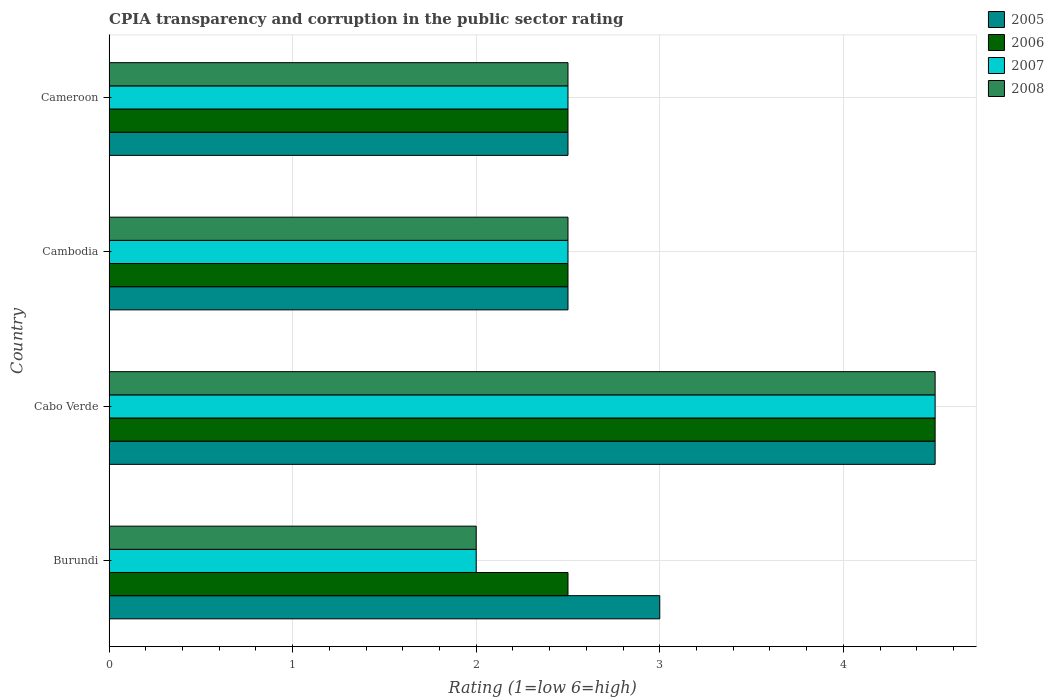How many groups of bars are there?
Make the answer very short. 4. Are the number of bars on each tick of the Y-axis equal?
Provide a short and direct response. Yes. How many bars are there on the 1st tick from the bottom?
Offer a very short reply. 4. What is the label of the 2nd group of bars from the top?
Your response must be concise. Cambodia. Across all countries, what is the maximum CPIA rating in 2006?
Provide a succinct answer. 4.5. Across all countries, what is the minimum CPIA rating in 2007?
Offer a very short reply. 2. In which country was the CPIA rating in 2008 maximum?
Your answer should be very brief. Cabo Verde. In which country was the CPIA rating in 2007 minimum?
Offer a terse response. Burundi. What is the difference between the CPIA rating in 2007 in Burundi and that in Cameroon?
Make the answer very short. -0.5. What is the average CPIA rating in 2007 per country?
Ensure brevity in your answer.  2.88. What is the difference between the highest and the lowest CPIA rating in 2008?
Offer a terse response. 2.5. In how many countries, is the CPIA rating in 2005 greater than the average CPIA rating in 2005 taken over all countries?
Your answer should be very brief. 1. What does the 3rd bar from the top in Burundi represents?
Offer a very short reply. 2006. Are all the bars in the graph horizontal?
Give a very brief answer. Yes. How many countries are there in the graph?
Provide a short and direct response. 4. What is the difference between two consecutive major ticks on the X-axis?
Ensure brevity in your answer.  1. Where does the legend appear in the graph?
Offer a terse response. Top right. How many legend labels are there?
Your response must be concise. 4. How are the legend labels stacked?
Offer a very short reply. Vertical. What is the title of the graph?
Provide a succinct answer. CPIA transparency and corruption in the public sector rating. What is the label or title of the Y-axis?
Offer a terse response. Country. What is the Rating (1=low 6=high) in 2005 in Burundi?
Provide a short and direct response. 3. What is the Rating (1=low 6=high) in 2006 in Burundi?
Make the answer very short. 2.5. What is the Rating (1=low 6=high) in 2007 in Burundi?
Your answer should be very brief. 2. What is the Rating (1=low 6=high) in 2008 in Burundi?
Provide a short and direct response. 2. What is the Rating (1=low 6=high) of 2005 in Cabo Verde?
Your answer should be compact. 4.5. What is the Rating (1=low 6=high) in 2008 in Cabo Verde?
Give a very brief answer. 4.5. What is the Rating (1=low 6=high) of 2006 in Cambodia?
Offer a very short reply. 2.5. What is the Rating (1=low 6=high) in 2007 in Cambodia?
Your answer should be very brief. 2.5. What is the Rating (1=low 6=high) of 2006 in Cameroon?
Keep it short and to the point. 2.5. What is the Rating (1=low 6=high) of 2007 in Cameroon?
Offer a terse response. 2.5. Across all countries, what is the maximum Rating (1=low 6=high) of 2005?
Give a very brief answer. 4.5. Across all countries, what is the maximum Rating (1=low 6=high) in 2006?
Offer a very short reply. 4.5. Across all countries, what is the maximum Rating (1=low 6=high) in 2007?
Make the answer very short. 4.5. Across all countries, what is the maximum Rating (1=low 6=high) in 2008?
Your answer should be compact. 4.5. Across all countries, what is the minimum Rating (1=low 6=high) in 2006?
Ensure brevity in your answer.  2.5. Across all countries, what is the minimum Rating (1=low 6=high) in 2008?
Keep it short and to the point. 2. What is the total Rating (1=low 6=high) in 2006 in the graph?
Your answer should be very brief. 12. What is the total Rating (1=low 6=high) of 2007 in the graph?
Offer a terse response. 11.5. What is the difference between the Rating (1=low 6=high) of 2005 in Burundi and that in Cabo Verde?
Keep it short and to the point. -1.5. What is the difference between the Rating (1=low 6=high) in 2007 in Burundi and that in Cambodia?
Your answer should be very brief. -0.5. What is the difference between the Rating (1=low 6=high) in 2006 in Cabo Verde and that in Cambodia?
Your answer should be compact. 2. What is the difference between the Rating (1=low 6=high) of 2007 in Cabo Verde and that in Cambodia?
Your answer should be compact. 2. What is the difference between the Rating (1=low 6=high) of 2008 in Cabo Verde and that in Cambodia?
Provide a succinct answer. 2. What is the difference between the Rating (1=low 6=high) in 2005 in Cambodia and that in Cameroon?
Provide a short and direct response. 0. What is the difference between the Rating (1=low 6=high) in 2008 in Cambodia and that in Cameroon?
Offer a terse response. 0. What is the difference between the Rating (1=low 6=high) in 2005 in Burundi and the Rating (1=low 6=high) in 2008 in Cabo Verde?
Ensure brevity in your answer.  -1.5. What is the difference between the Rating (1=low 6=high) in 2006 in Burundi and the Rating (1=low 6=high) in 2007 in Cabo Verde?
Provide a succinct answer. -2. What is the difference between the Rating (1=low 6=high) of 2006 in Burundi and the Rating (1=low 6=high) of 2008 in Cabo Verde?
Keep it short and to the point. -2. What is the difference between the Rating (1=low 6=high) in 2005 in Burundi and the Rating (1=low 6=high) in 2007 in Cameroon?
Provide a succinct answer. 0.5. What is the difference between the Rating (1=low 6=high) in 2006 in Burundi and the Rating (1=low 6=high) in 2007 in Cameroon?
Offer a very short reply. 0. What is the difference between the Rating (1=low 6=high) in 2005 in Cabo Verde and the Rating (1=low 6=high) in 2006 in Cambodia?
Offer a very short reply. 2. What is the difference between the Rating (1=low 6=high) in 2005 in Cabo Verde and the Rating (1=low 6=high) in 2007 in Cambodia?
Your response must be concise. 2. What is the difference between the Rating (1=low 6=high) of 2005 in Cabo Verde and the Rating (1=low 6=high) of 2008 in Cambodia?
Make the answer very short. 2. What is the difference between the Rating (1=low 6=high) in 2006 in Cabo Verde and the Rating (1=low 6=high) in 2007 in Cambodia?
Your response must be concise. 2. What is the difference between the Rating (1=low 6=high) of 2006 in Cabo Verde and the Rating (1=low 6=high) of 2008 in Cambodia?
Provide a short and direct response. 2. What is the difference between the Rating (1=low 6=high) in 2007 in Cabo Verde and the Rating (1=low 6=high) in 2008 in Cambodia?
Your answer should be very brief. 2. What is the difference between the Rating (1=low 6=high) in 2005 in Cabo Verde and the Rating (1=low 6=high) in 2006 in Cameroon?
Your response must be concise. 2. What is the difference between the Rating (1=low 6=high) of 2005 in Cabo Verde and the Rating (1=low 6=high) of 2008 in Cameroon?
Ensure brevity in your answer.  2. What is the difference between the Rating (1=low 6=high) of 2006 in Cabo Verde and the Rating (1=low 6=high) of 2008 in Cameroon?
Your answer should be very brief. 2. What is the difference between the Rating (1=low 6=high) in 2007 in Cabo Verde and the Rating (1=low 6=high) in 2008 in Cameroon?
Your answer should be compact. 2. What is the difference between the Rating (1=low 6=high) in 2005 in Cambodia and the Rating (1=low 6=high) in 2008 in Cameroon?
Provide a short and direct response. 0. What is the difference between the Rating (1=low 6=high) in 2006 in Cambodia and the Rating (1=low 6=high) in 2007 in Cameroon?
Ensure brevity in your answer.  0. What is the difference between the Rating (1=low 6=high) in 2006 in Cambodia and the Rating (1=low 6=high) in 2008 in Cameroon?
Your answer should be very brief. 0. What is the average Rating (1=low 6=high) of 2005 per country?
Ensure brevity in your answer.  3.12. What is the average Rating (1=low 6=high) of 2007 per country?
Your answer should be compact. 2.88. What is the average Rating (1=low 6=high) in 2008 per country?
Keep it short and to the point. 2.88. What is the difference between the Rating (1=low 6=high) in 2005 and Rating (1=low 6=high) in 2007 in Burundi?
Make the answer very short. 1. What is the difference between the Rating (1=low 6=high) of 2006 and Rating (1=low 6=high) of 2008 in Burundi?
Offer a very short reply. 0.5. What is the difference between the Rating (1=low 6=high) of 2005 and Rating (1=low 6=high) of 2006 in Cabo Verde?
Your answer should be compact. 0. What is the difference between the Rating (1=low 6=high) of 2005 and Rating (1=low 6=high) of 2007 in Cabo Verde?
Offer a terse response. 0. What is the difference between the Rating (1=low 6=high) of 2005 and Rating (1=low 6=high) of 2008 in Cabo Verde?
Your answer should be compact. 0. What is the difference between the Rating (1=low 6=high) in 2006 and Rating (1=low 6=high) in 2008 in Cabo Verde?
Your response must be concise. 0. What is the difference between the Rating (1=low 6=high) in 2005 and Rating (1=low 6=high) in 2006 in Cambodia?
Keep it short and to the point. 0. What is the difference between the Rating (1=low 6=high) in 2007 and Rating (1=low 6=high) in 2008 in Cambodia?
Ensure brevity in your answer.  0. What is the difference between the Rating (1=low 6=high) in 2005 and Rating (1=low 6=high) in 2008 in Cameroon?
Offer a terse response. 0. What is the ratio of the Rating (1=low 6=high) in 2005 in Burundi to that in Cabo Verde?
Offer a terse response. 0.67. What is the ratio of the Rating (1=low 6=high) in 2006 in Burundi to that in Cabo Verde?
Offer a terse response. 0.56. What is the ratio of the Rating (1=low 6=high) in 2007 in Burundi to that in Cabo Verde?
Keep it short and to the point. 0.44. What is the ratio of the Rating (1=low 6=high) of 2008 in Burundi to that in Cabo Verde?
Offer a very short reply. 0.44. What is the ratio of the Rating (1=low 6=high) of 2005 in Burundi to that in Cambodia?
Keep it short and to the point. 1.2. What is the ratio of the Rating (1=low 6=high) of 2006 in Burundi to that in Cambodia?
Offer a terse response. 1. What is the ratio of the Rating (1=low 6=high) of 2007 in Burundi to that in Cambodia?
Your answer should be compact. 0.8. What is the ratio of the Rating (1=low 6=high) of 2006 in Burundi to that in Cameroon?
Your answer should be very brief. 1. What is the ratio of the Rating (1=low 6=high) of 2008 in Burundi to that in Cameroon?
Your answer should be compact. 0.8. What is the ratio of the Rating (1=low 6=high) of 2005 in Cabo Verde to that in Cambodia?
Keep it short and to the point. 1.8. What is the ratio of the Rating (1=low 6=high) in 2006 in Cabo Verde to that in Cambodia?
Offer a terse response. 1.8. What is the ratio of the Rating (1=low 6=high) in 2007 in Cabo Verde to that in Cambodia?
Offer a terse response. 1.8. What is the ratio of the Rating (1=low 6=high) in 2008 in Cabo Verde to that in Cambodia?
Offer a very short reply. 1.8. What is the ratio of the Rating (1=low 6=high) of 2005 in Cabo Verde to that in Cameroon?
Keep it short and to the point. 1.8. What is the ratio of the Rating (1=low 6=high) in 2006 in Cabo Verde to that in Cameroon?
Offer a very short reply. 1.8. What is the ratio of the Rating (1=low 6=high) in 2007 in Cabo Verde to that in Cameroon?
Your answer should be compact. 1.8. What is the ratio of the Rating (1=low 6=high) of 2008 in Cabo Verde to that in Cameroon?
Offer a very short reply. 1.8. What is the ratio of the Rating (1=low 6=high) in 2005 in Cambodia to that in Cameroon?
Make the answer very short. 1. What is the ratio of the Rating (1=low 6=high) in 2006 in Cambodia to that in Cameroon?
Make the answer very short. 1. What is the ratio of the Rating (1=low 6=high) of 2007 in Cambodia to that in Cameroon?
Ensure brevity in your answer.  1. What is the difference between the highest and the second highest Rating (1=low 6=high) of 2008?
Give a very brief answer. 2. What is the difference between the highest and the lowest Rating (1=low 6=high) in 2006?
Provide a succinct answer. 2. What is the difference between the highest and the lowest Rating (1=low 6=high) in 2007?
Your answer should be compact. 2.5. 